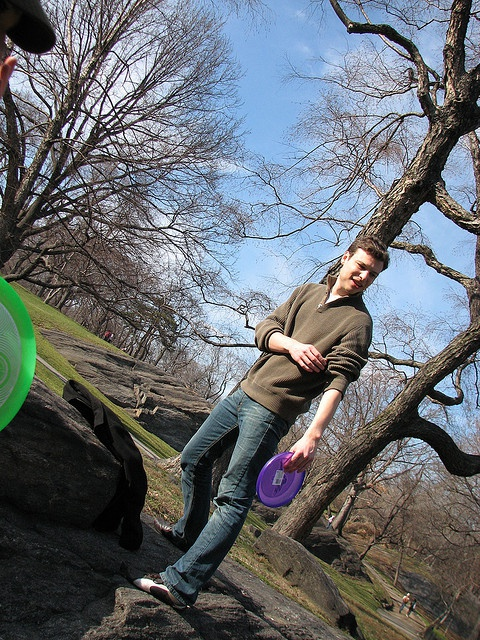Describe the objects in this image and their specific colors. I can see people in black, gray, darkgray, and white tones, frisbee in black, green, and teal tones, frisbee in black, purple, and navy tones, people in black, maroon, gray, and brown tones, and people in black, gray, brown, and maroon tones in this image. 